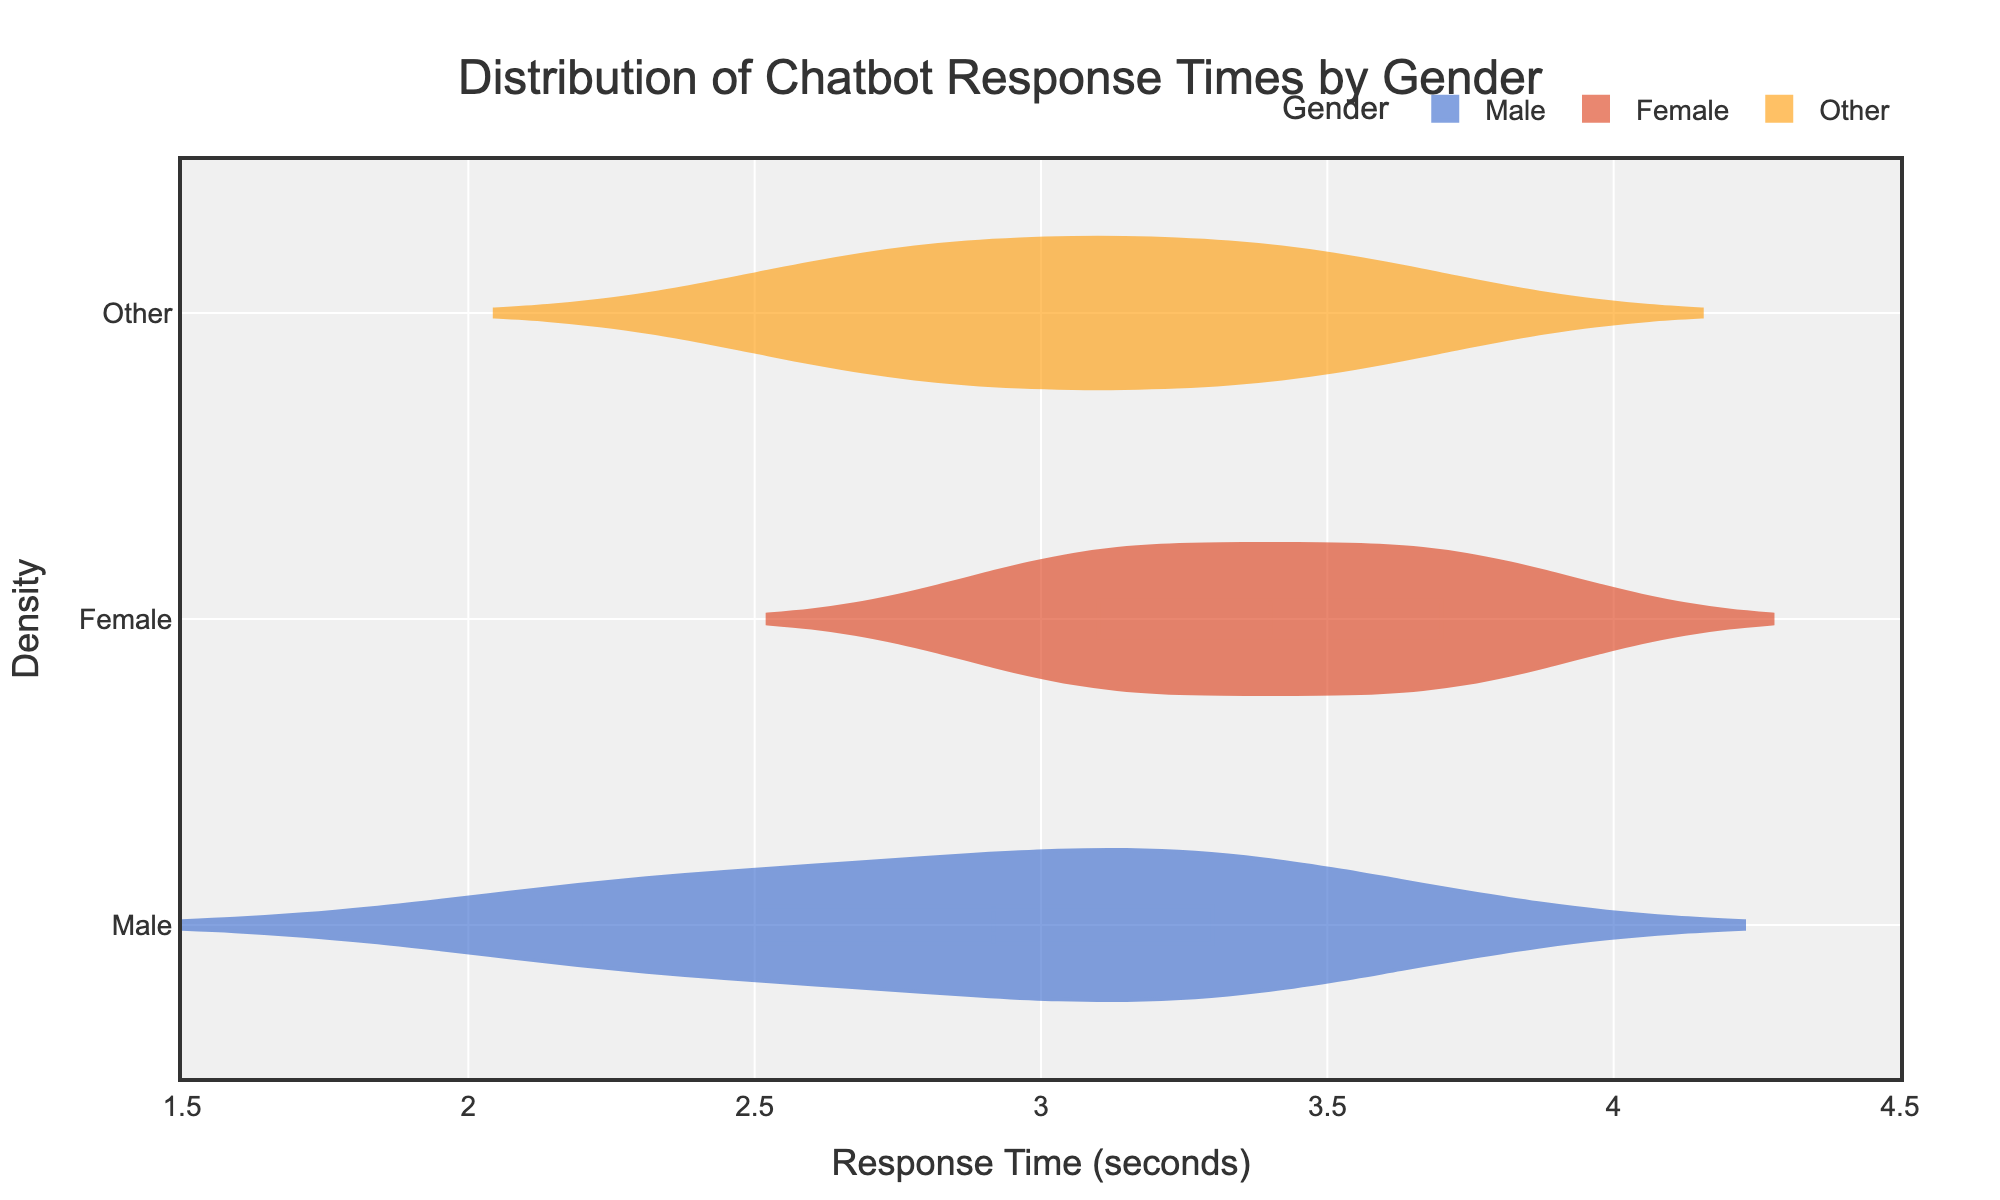What is the title of the plot? The title of the plot is usually located at the top and is the largest text within the plot area. In this case, the title states the main purpose of the plot.
Answer: Distribution of Chatbot Response Times by Gender What are the x-axis labels? The x-axis typically provides information about the measurements in the plot. Here, the x-axis labels display the different ranges or categories measured, according to the axis title and ticks.
Answer: Response Time (seconds) Which gender has the highest mean response time? On a violin plot, the mean line is often represented. By checking which gender's mean line is at the highest position based on the figure, we can determine the group.
Answer: Female What is the approximate range of response times for the 'Male' gender? The violin plot's width represents the distribution density at various response times. By looking at where the distribution for 'Male' starts and ends, the range can be estimated.
Answer: 2.2 - 3.5 seconds How do the mean response times compare between 'Male' and 'Female' genders? By comparing the mean lines for 'Male' and 'Female' on the violin plot, we can determine which one is higher or if they are equal. In this case, it involves observing the horizontal position of the mean line for each gender.
Answer: Female mean response time is higher than Male Which gender demonstrates the most spread in response times? The spread is indicated by the width and length of each violin plot. We observe the range of the data points along the x-axis for each gender to determine this.
Answer: Female What is the shape of the distribution for 'Other' gender? The shape of the violin plot for 'Other' can be inferred by observing whether it is skewed to one side, has long tails, or is evenly distributed around the mean. This assessment depends on the visual representation.
Answer: Symmetrical What demographic has the shortest response time segment on the plot? Checking each gender's lower bound of the response time segment, the gender with the lowest starting point on the x-axis indicates the shortest response time segment.
Answer: Male How does the density of response times in the 'Female' group differ from the 'Other' group? By looking at the width of the violin plot at various points along the response time axis, we can determine areas of higher and lower density for each group, and compare them.
Answer: Female has higher density at ~3.5 seconds, while 'Other' is more evenly spread Which gender has the narrowest interquartile range (IQR) for response time? The IQR can be determined by examining the box plots within each violin plot. The narrowest box indicates the smallest IQR.
Answer: Male 